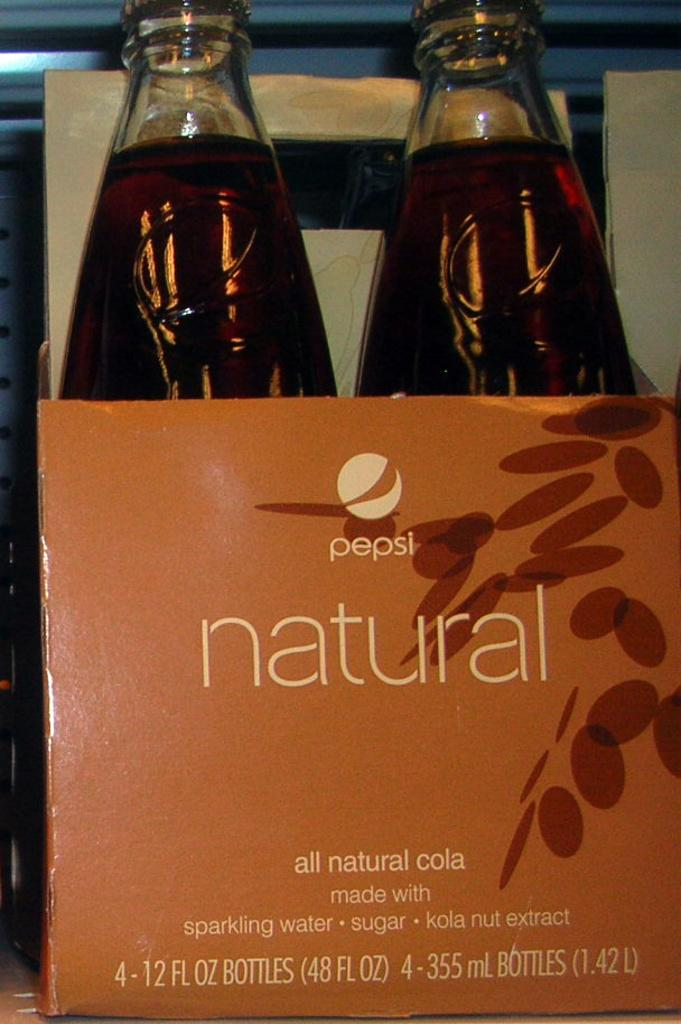<image>
Relay a brief, clear account of the picture shown. A 2 pack of pepsi natural cola bottles 